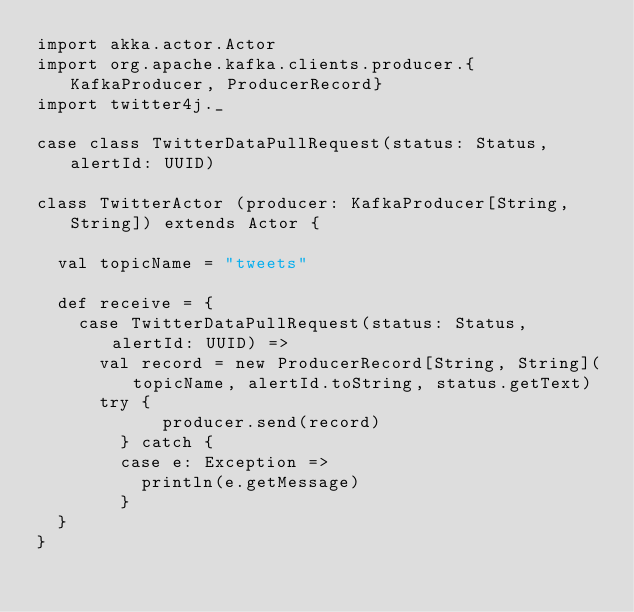<code> <loc_0><loc_0><loc_500><loc_500><_Scala_>import akka.actor.Actor
import org.apache.kafka.clients.producer.{KafkaProducer, ProducerRecord}
import twitter4j._

case class TwitterDataPullRequest(status: Status, alertId: UUID)

class TwitterActor (producer: KafkaProducer[String,String]) extends Actor {

  val topicName = "tweets"

  def receive = {
    case TwitterDataPullRequest(status: Status, alertId: UUID) =>
      val record = new ProducerRecord[String, String](topicName, alertId.toString, status.getText)
      try {
     		producer.send(record)
    	} catch {
        case e: Exception =>
          println(e.getMessage)
    	}
  }
}
</code> 